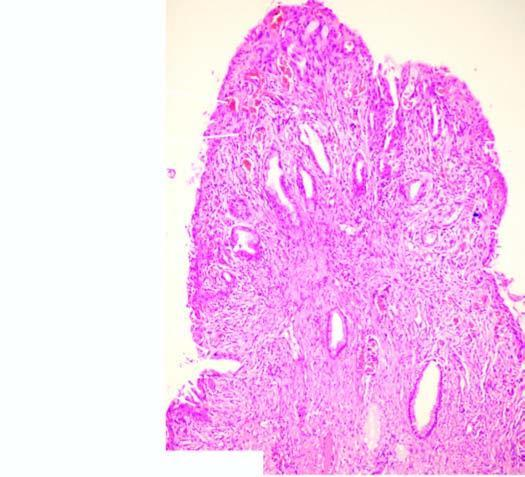s aldh covered by endocervical mucosa with squamous metaplasia?
Answer the question using a single word or phrase. No 